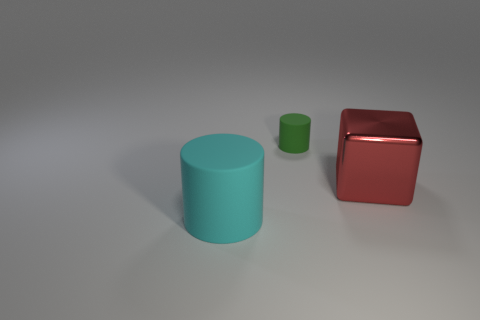Subtract all cyan cylinders. How many cylinders are left? 1 Subtract all cylinders. How many objects are left? 1 Subtract 1 cylinders. How many cylinders are left? 1 Add 3 tiny purple blocks. How many objects exist? 6 Subtract all green cylinders. Subtract all brown balls. How many cylinders are left? 1 Subtract all cyan cylinders. How many brown cubes are left? 0 Subtract all big cyan matte objects. Subtract all tiny green things. How many objects are left? 1 Add 1 red shiny blocks. How many red shiny blocks are left? 2 Add 1 large cyan spheres. How many large cyan spheres exist? 1 Subtract 0 green cubes. How many objects are left? 3 